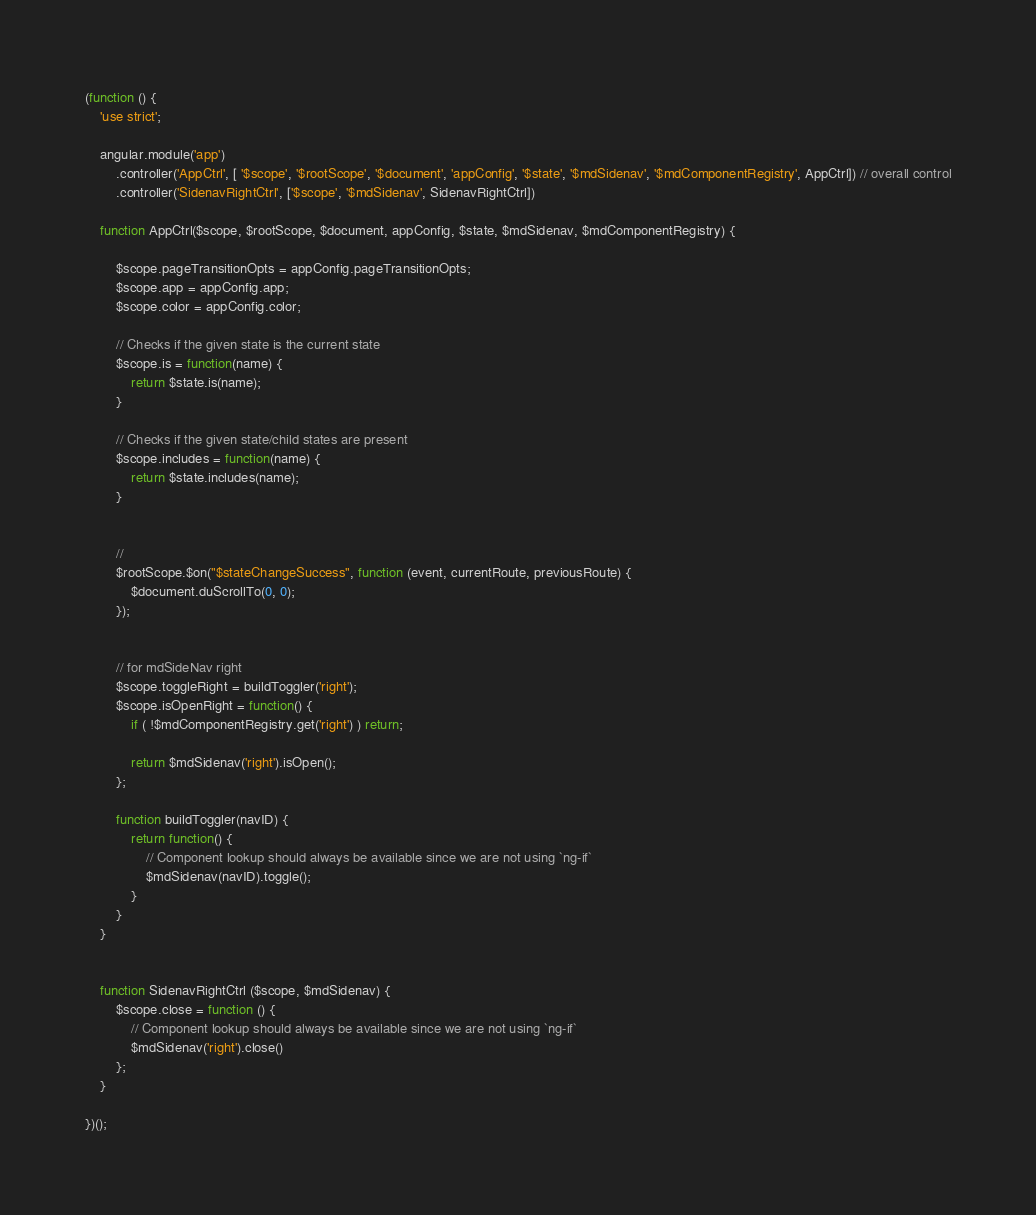<code> <loc_0><loc_0><loc_500><loc_500><_JavaScript_>(function () {
    'use strict';

    angular.module('app')
        .controller('AppCtrl', [ '$scope', '$rootScope', '$document', 'appConfig', '$state', '$mdSidenav', '$mdComponentRegistry', AppCtrl]) // overall control
        .controller('SidenavRightCtrl', ['$scope', '$mdSidenav', SidenavRightCtrl])
    
    function AppCtrl($scope, $rootScope, $document, appConfig, $state, $mdSidenav, $mdComponentRegistry) {

        $scope.pageTransitionOpts = appConfig.pageTransitionOpts;
        $scope.app = appConfig.app;
        $scope.color = appConfig.color;

        // Checks if the given state is the current state
        $scope.is = function(name) {
            return $state.is(name);
        }

        // Checks if the given state/child states are present
        $scope.includes = function(name) {
            return $state.includes(name);
        }


        // 
        $rootScope.$on("$stateChangeSuccess", function (event, currentRoute, previousRoute) {
            $document.duScrollTo(0, 0);
        });


        // for mdSideNav right
        $scope.toggleRight = buildToggler('right');
        $scope.isOpenRight = function() {
            if ( !$mdComponentRegistry.get('right') ) return;

            return $mdSidenav('right').isOpen();
        };

        function buildToggler(navID) {
            return function() {
                // Component lookup should always be available since we are not using `ng-if`
                $mdSidenav(navID).toggle();
            }
        }
    }


    function SidenavRightCtrl ($scope, $mdSidenav) {
        $scope.close = function () {
            // Component lookup should always be available since we are not using `ng-if`
            $mdSidenav('right').close()
        };
    }

})(); </code> 